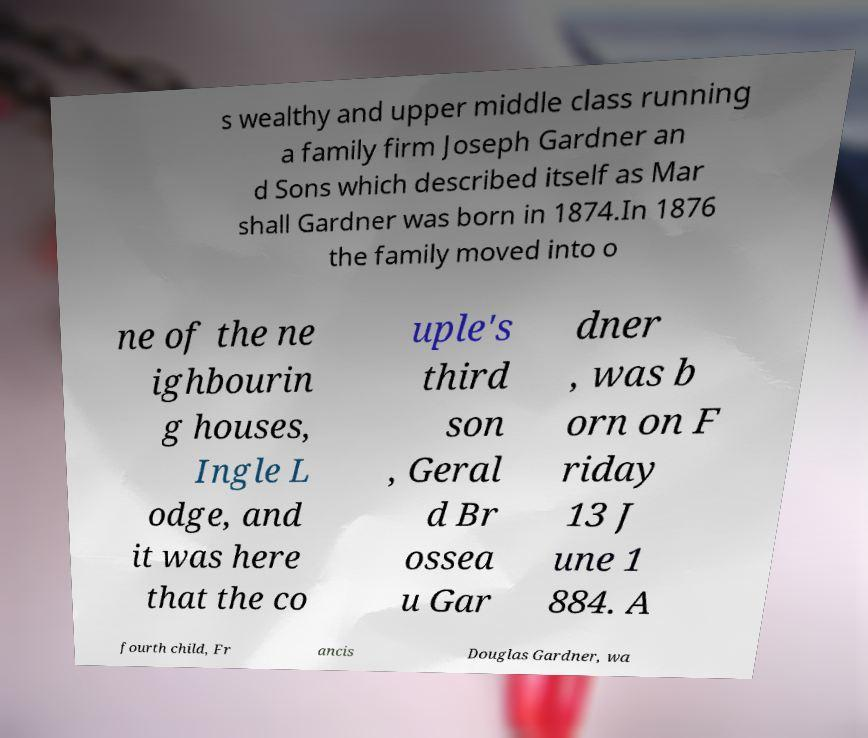For documentation purposes, I need the text within this image transcribed. Could you provide that? s wealthy and upper middle class running a family firm Joseph Gardner an d Sons which described itself as Mar shall Gardner was born in 1874.In 1876 the family moved into o ne of the ne ighbourin g houses, Ingle L odge, and it was here that the co uple's third son , Geral d Br ossea u Gar dner , was b orn on F riday 13 J une 1 884. A fourth child, Fr ancis Douglas Gardner, wa 